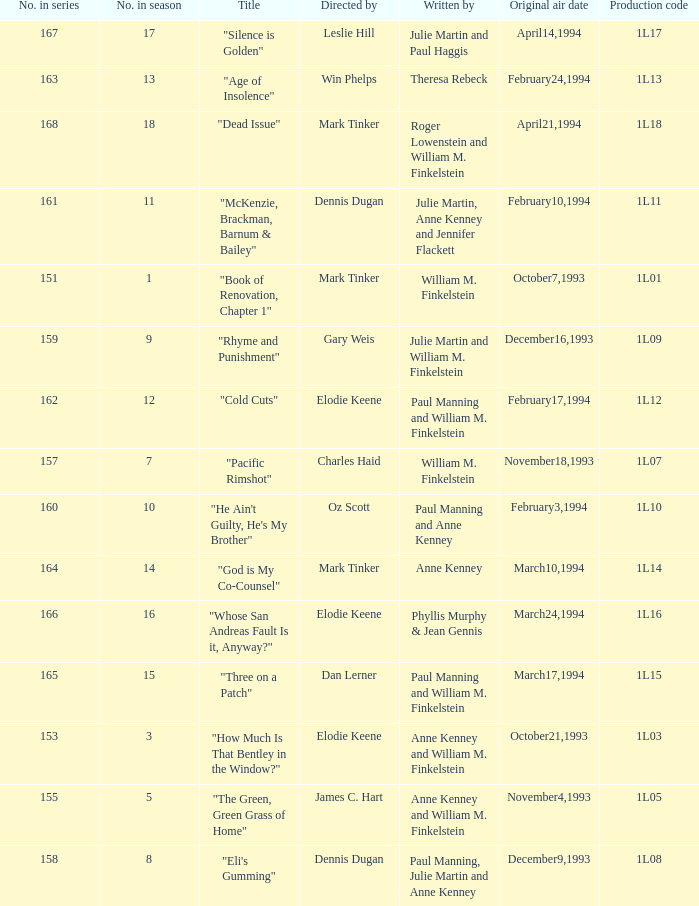Name the production code for theresa rebeck 1L13. 